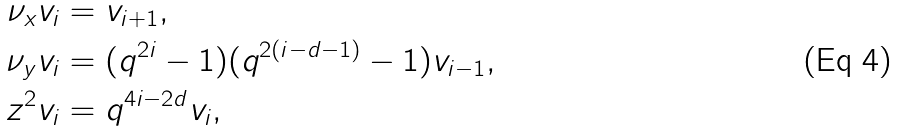Convert formula to latex. <formula><loc_0><loc_0><loc_500><loc_500>\nu _ { x } v _ { i } & = v _ { i + 1 } , \\ \nu _ { y } v _ { i } & = ( q ^ { 2 i } - 1 ) ( q ^ { 2 ( i - d - 1 ) } - 1 ) v _ { i - 1 } , \\ z ^ { 2 } v _ { i } & = q ^ { 4 i - 2 d } v _ { i } ,</formula> 